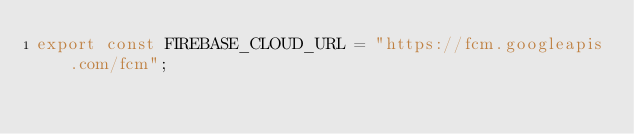Convert code to text. <code><loc_0><loc_0><loc_500><loc_500><_TypeScript_>export const FIREBASE_CLOUD_URL = "https://fcm.googleapis.com/fcm";</code> 